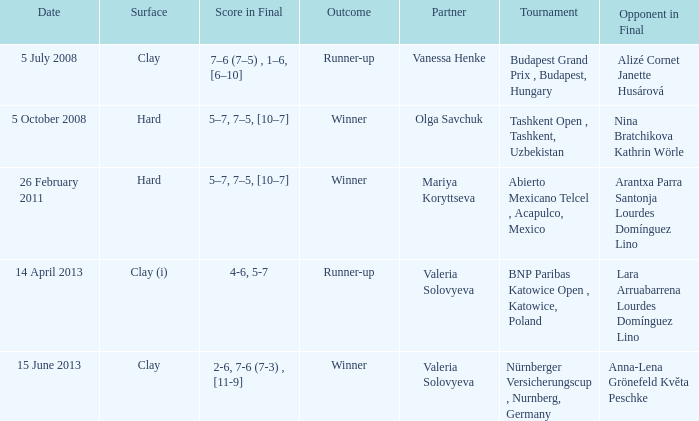Which partner was on 14 april 2013? Valeria Solovyeva. 